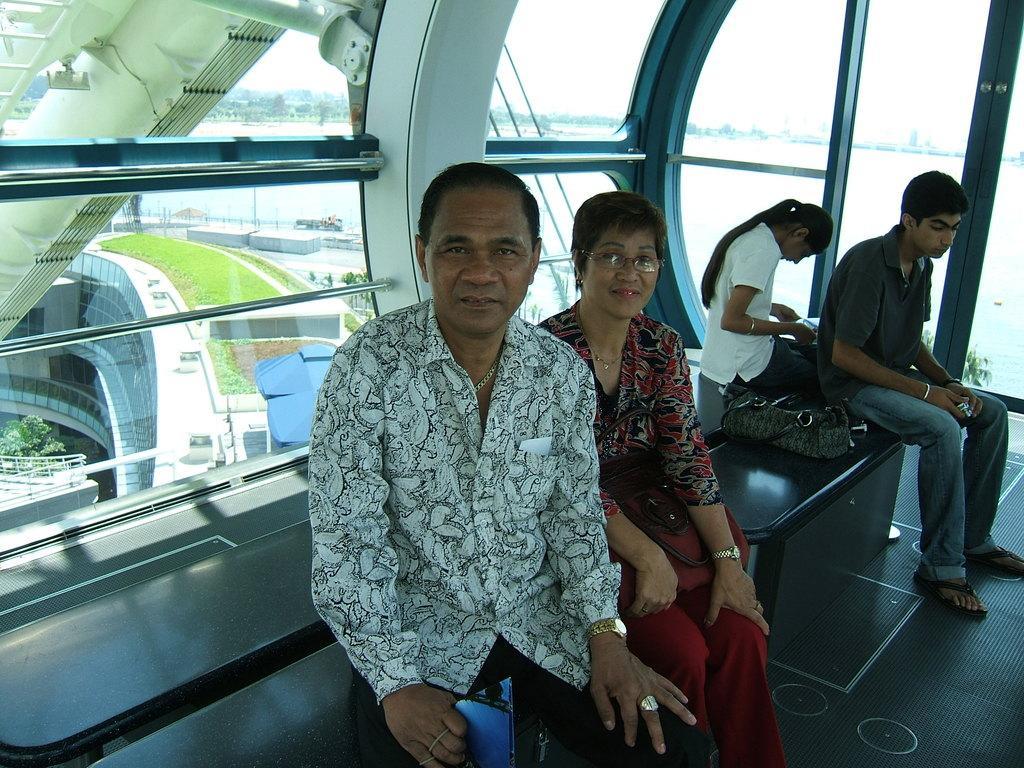In one or two sentences, can you explain what this image depicts? In this image, we can see persons wearing clothes and sitting on the bench. There is a bag on the right side of the image. In the background, we can see a glass wall. 